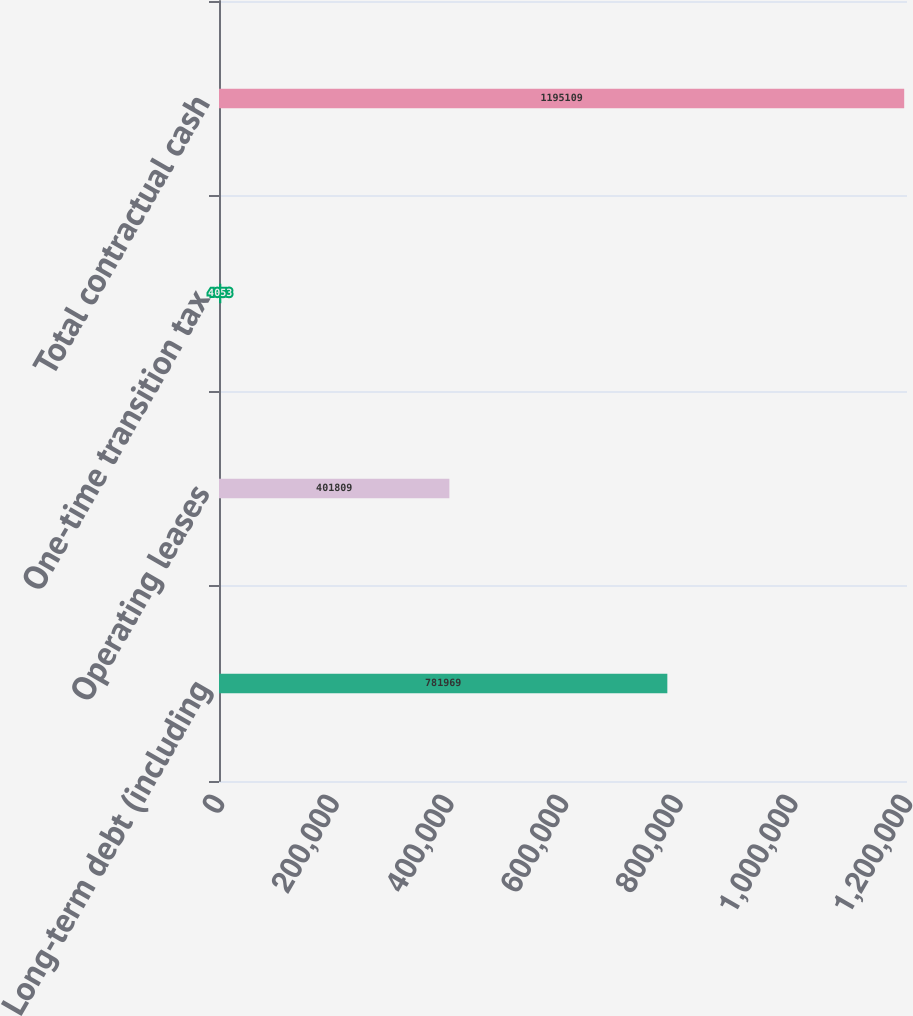Convert chart to OTSL. <chart><loc_0><loc_0><loc_500><loc_500><bar_chart><fcel>Long-term debt (including<fcel>Operating leases<fcel>One-time transition tax<fcel>Total contractual cash<nl><fcel>781969<fcel>401809<fcel>4053<fcel>1.19511e+06<nl></chart> 